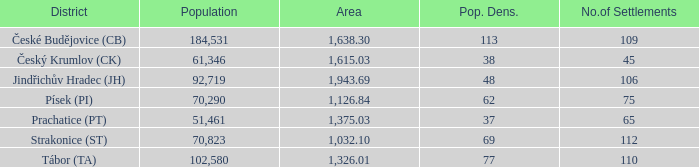What is the population density of the area with a population larger than 92,719? 2.0. 